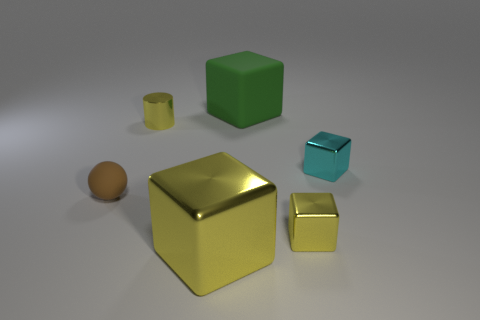How many yellow cubes are to the left of the small yellow thing in front of the tiny metallic object that is to the left of the rubber block?
Your answer should be compact. 1. There is a cyan thing that is the same shape as the big green thing; what is it made of?
Provide a short and direct response. Metal. Is there any other thing that is the same material as the tiny cylinder?
Provide a short and direct response. Yes. There is a small metal cube in front of the small brown object; what is its color?
Keep it short and to the point. Yellow. Do the tiny cylinder and the big cube behind the tiny yellow metallic block have the same material?
Give a very brief answer. No. What is the green cube made of?
Give a very brief answer. Rubber. What shape is the big green object that is made of the same material as the sphere?
Offer a very short reply. Cube. What number of other things are there of the same shape as the small rubber object?
Ensure brevity in your answer.  0. How many tiny brown matte objects are right of the brown matte sphere?
Offer a very short reply. 0. Is the size of the yellow shiny cube that is behind the large metallic cube the same as the matte thing that is behind the brown thing?
Your answer should be compact. No. 